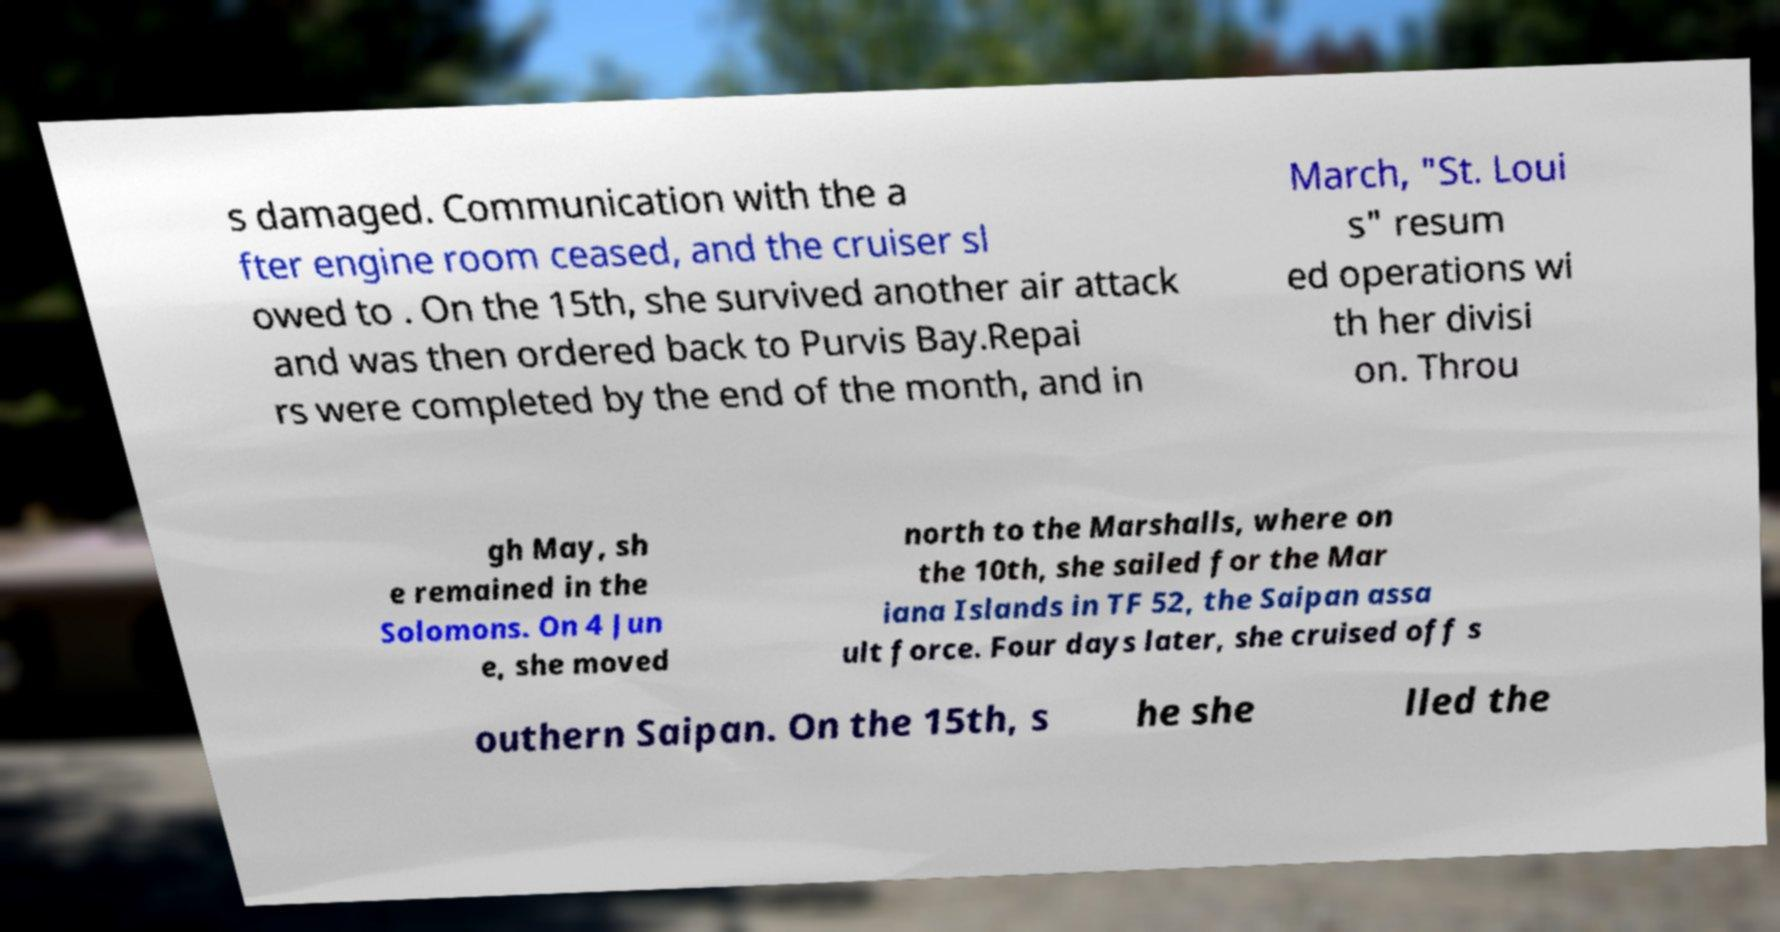What messages or text are displayed in this image? I need them in a readable, typed format. s damaged. Communication with the a fter engine room ceased, and the cruiser sl owed to . On the 15th, she survived another air attack and was then ordered back to Purvis Bay.Repai rs were completed by the end of the month, and in March, "St. Loui s" resum ed operations wi th her divisi on. Throu gh May, sh e remained in the Solomons. On 4 Jun e, she moved north to the Marshalls, where on the 10th, she sailed for the Mar iana Islands in TF 52, the Saipan assa ult force. Four days later, she cruised off s outhern Saipan. On the 15th, s he she lled the 